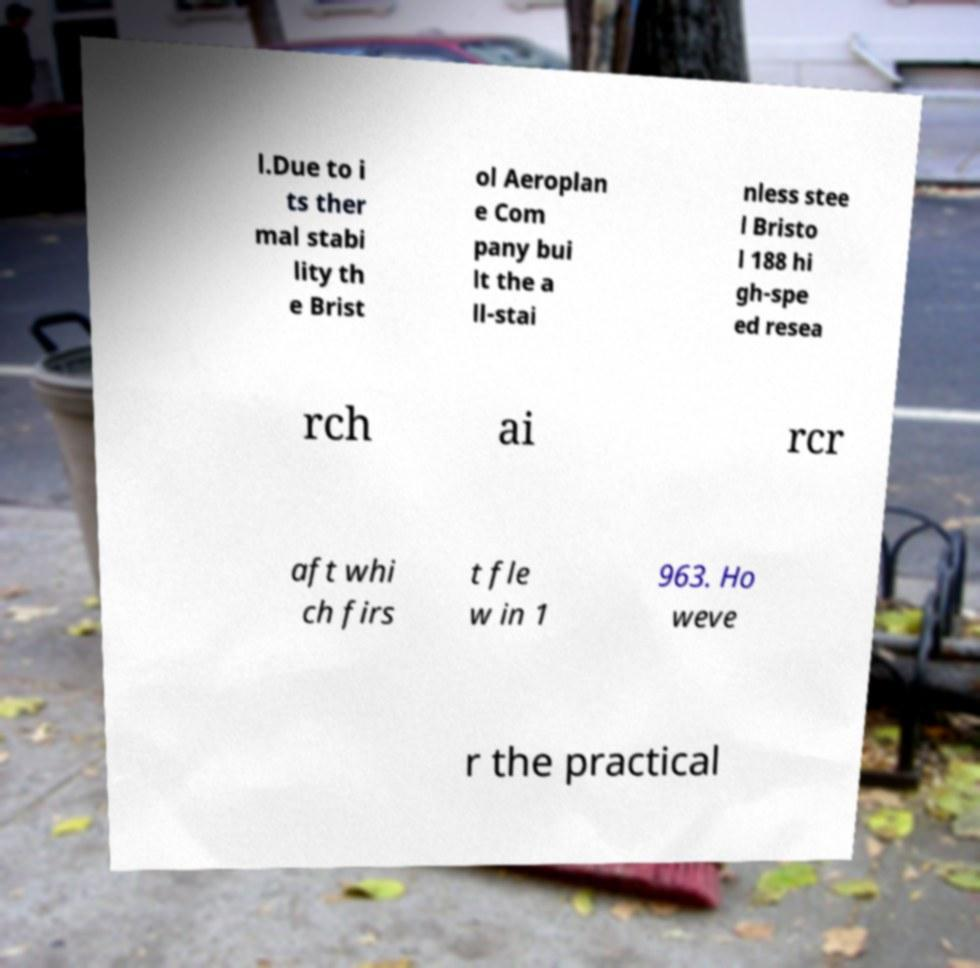Please identify and transcribe the text found in this image. l.Due to i ts ther mal stabi lity th e Brist ol Aeroplan e Com pany bui lt the a ll-stai nless stee l Bristo l 188 hi gh-spe ed resea rch ai rcr aft whi ch firs t fle w in 1 963. Ho weve r the practical 